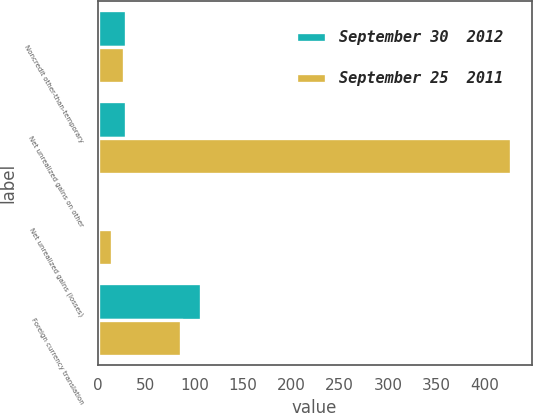Convert chart. <chart><loc_0><loc_0><loc_500><loc_500><stacked_bar_chart><ecel><fcel>Noncredit other-than-temporary<fcel>Net unrealized gains on other<fcel>Net unrealized gains (losses)<fcel>Foreign currency translation<nl><fcel>September 30  2012<fcel>29<fcel>29<fcel>2<fcel>107<nl><fcel>September 25  2011<fcel>27<fcel>427<fcel>15<fcel>86<nl></chart> 